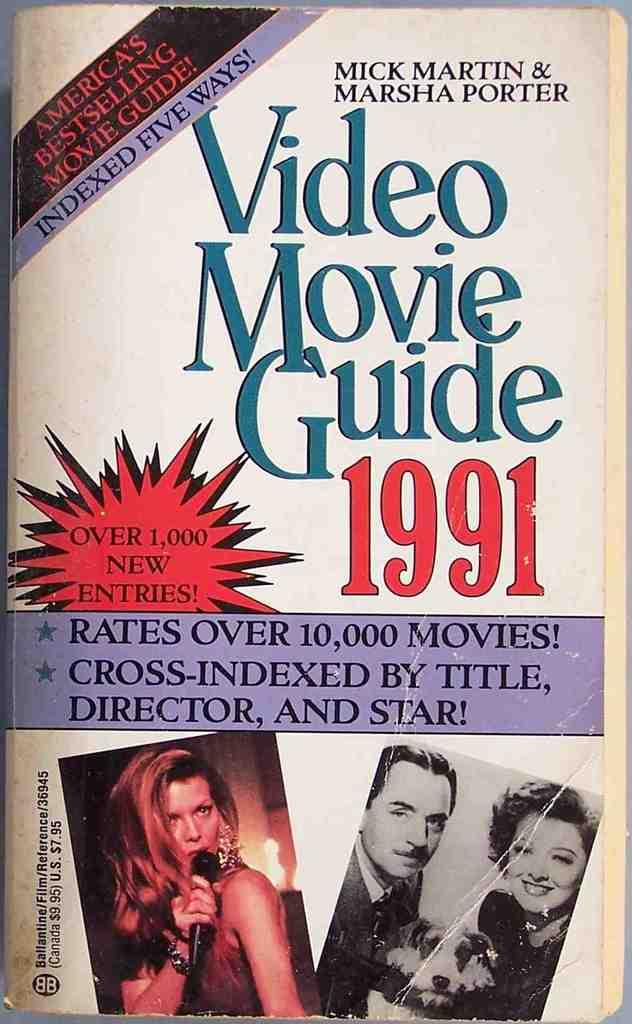What is the main subject of the image? The main subject of the image is a book. What type of content is depicted on the book? The book has illustrations of humans on it. Is there any text on the book? Yes, text is visible on the book. What type of lamp is shown in the image? There is no lamp present in the image; it shows a top view of a book with illustrations of humans and text. What type of drug is being discussed in the text on the book? There is no mention of drugs in the image or the text on the book. 